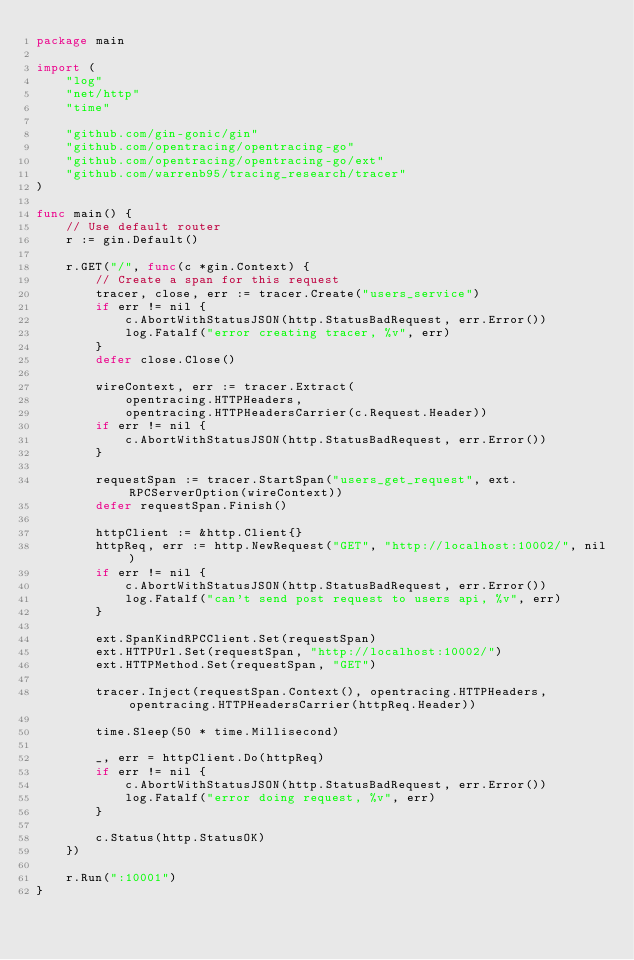<code> <loc_0><loc_0><loc_500><loc_500><_Go_>package main

import (
	"log"
	"net/http"
	"time"

	"github.com/gin-gonic/gin"
	"github.com/opentracing/opentracing-go"
	"github.com/opentracing/opentracing-go/ext"
	"github.com/warrenb95/tracing_research/tracer"
)

func main() {
	// Use default router
	r := gin.Default()

	r.GET("/", func(c *gin.Context) {
		// Create a span for this request
		tracer, close, err := tracer.Create("users_service")
		if err != nil {
			c.AbortWithStatusJSON(http.StatusBadRequest, err.Error())
			log.Fatalf("error creating tracer, %v", err)
		}
		defer close.Close()

		wireContext, err := tracer.Extract(
			opentracing.HTTPHeaders,
			opentracing.HTTPHeadersCarrier(c.Request.Header))
		if err != nil {
			c.AbortWithStatusJSON(http.StatusBadRequest, err.Error())
		}

		requestSpan := tracer.StartSpan("users_get_request", ext.RPCServerOption(wireContext))
		defer requestSpan.Finish()

		httpClient := &http.Client{}
		httpReq, err := http.NewRequest("GET", "http://localhost:10002/", nil)
		if err != nil {
			c.AbortWithStatusJSON(http.StatusBadRequest, err.Error())
			log.Fatalf("can't send post request to users api, %v", err)
		}

		ext.SpanKindRPCClient.Set(requestSpan)
		ext.HTTPUrl.Set(requestSpan, "http://localhost:10002/")
		ext.HTTPMethod.Set(requestSpan, "GET")

		tracer.Inject(requestSpan.Context(), opentracing.HTTPHeaders, opentracing.HTTPHeadersCarrier(httpReq.Header))

		time.Sleep(50 * time.Millisecond)

		_, err = httpClient.Do(httpReq)
		if err != nil {
			c.AbortWithStatusJSON(http.StatusBadRequest, err.Error())
			log.Fatalf("error doing request, %v", err)
		}

		c.Status(http.StatusOK)
	})

	r.Run(":10001")
}
</code> 